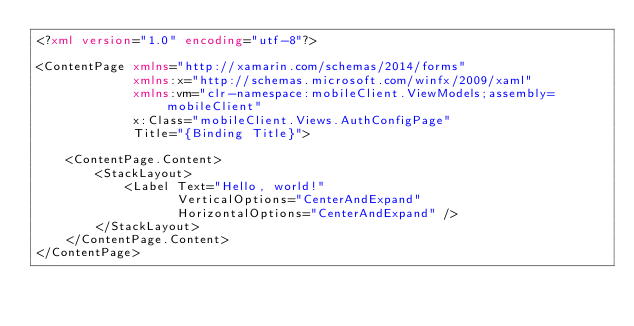<code> <loc_0><loc_0><loc_500><loc_500><_XML_><?xml version="1.0" encoding="utf-8"?>

<ContentPage xmlns="http://xamarin.com/schemas/2014/forms"
             xmlns:x="http://schemas.microsoft.com/winfx/2009/xaml"
             xmlns:vm="clr-namespace:mobileClient.ViewModels;assembly=mobileClient"
             x:Class="mobileClient.Views.AuthConfigPage"
             Title="{Binding Title}">
    
    <ContentPage.Content>
        <StackLayout>
            <Label Text="Hello, world!"
                   VerticalOptions="CenterAndExpand"
                   HorizontalOptions="CenterAndExpand" />
        </StackLayout>
    </ContentPage.Content>
</ContentPage></code> 